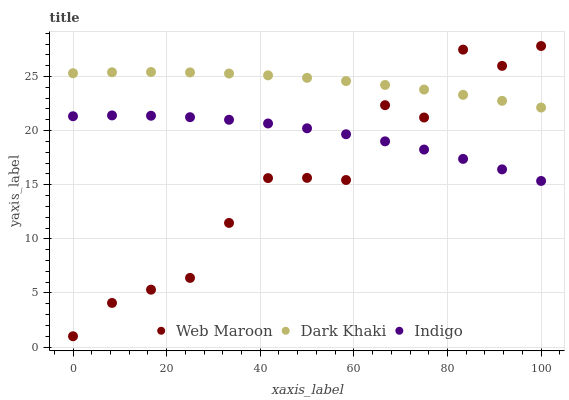Does Web Maroon have the minimum area under the curve?
Answer yes or no. Yes. Does Dark Khaki have the maximum area under the curve?
Answer yes or no. Yes. Does Indigo have the minimum area under the curve?
Answer yes or no. No. Does Indigo have the maximum area under the curve?
Answer yes or no. No. Is Dark Khaki the smoothest?
Answer yes or no. Yes. Is Web Maroon the roughest?
Answer yes or no. Yes. Is Indigo the smoothest?
Answer yes or no. No. Is Indigo the roughest?
Answer yes or no. No. Does Web Maroon have the lowest value?
Answer yes or no. Yes. Does Indigo have the lowest value?
Answer yes or no. No. Does Web Maroon have the highest value?
Answer yes or no. Yes. Does Indigo have the highest value?
Answer yes or no. No. Is Indigo less than Dark Khaki?
Answer yes or no. Yes. Is Dark Khaki greater than Indigo?
Answer yes or no. Yes. Does Indigo intersect Web Maroon?
Answer yes or no. Yes. Is Indigo less than Web Maroon?
Answer yes or no. No. Is Indigo greater than Web Maroon?
Answer yes or no. No. Does Indigo intersect Dark Khaki?
Answer yes or no. No. 